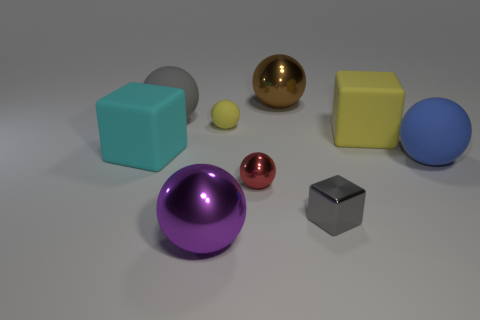Subtract all large rubber blocks. How many blocks are left? 1 Subtract all cubes. How many objects are left? 6 Subtract 3 balls. How many balls are left? 3 Subtract all blue spheres. How many spheres are left? 5 Subtract all cyan things. Subtract all big brown balls. How many objects are left? 7 Add 2 small metallic balls. How many small metallic balls are left? 3 Add 8 green shiny spheres. How many green shiny spheres exist? 8 Subtract 0 red cylinders. How many objects are left? 9 Subtract all red spheres. Subtract all brown cubes. How many spheres are left? 5 